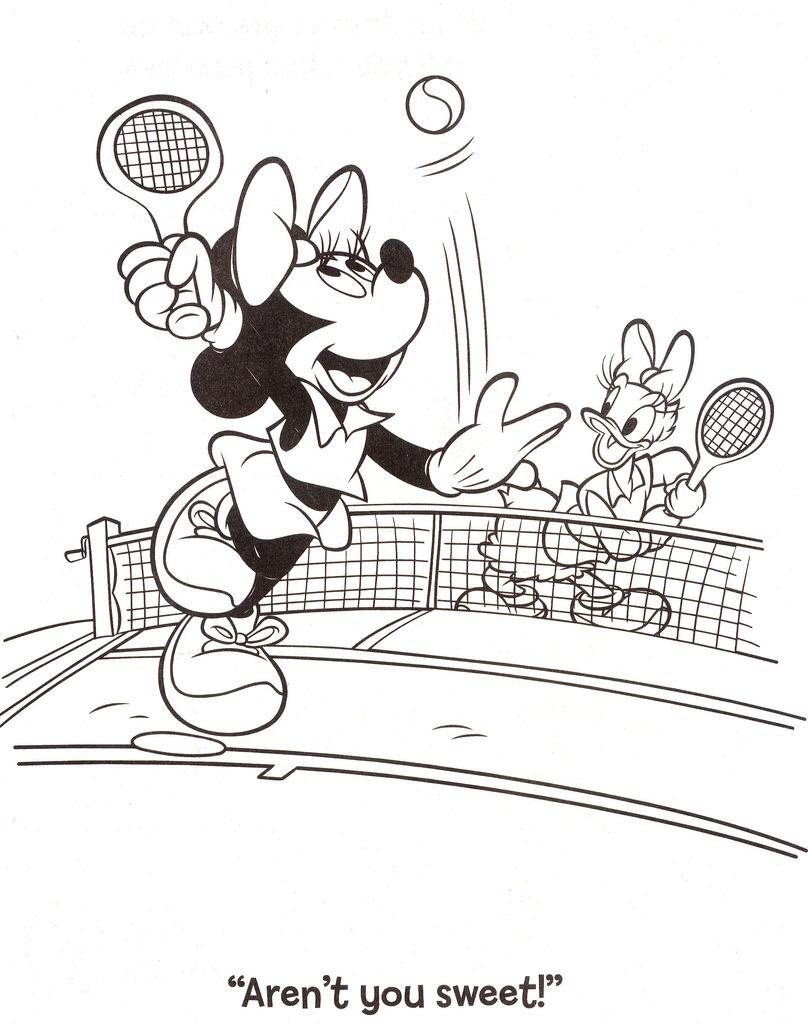Who are the characters present in the image? Mickey Mouse and Donald Duck are present in the image. What is the background or setting of the image? The image features a mesh and bats, suggesting a cave or similar environment. What object is visible in the image? A ball is visible in the image. Is there any text present in the image? Yes, there is text written at the bottom of the image. What type of suit is Mickey Mouse wearing in the image? Mickey Mouse is not wearing a suit in the image; he is wearing his typical red shorts and large yellow shoes. What type of club is depicted in the image? There is no club present in the image; it features Mickey Mouse, Donald Duck, a mesh, bats, a ball, and text. 